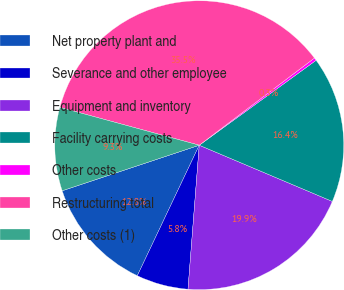<chart> <loc_0><loc_0><loc_500><loc_500><pie_chart><fcel>Net property plant and<fcel>Severance and other employee<fcel>Equipment and inventory<fcel>Facility carrying costs<fcel>Other costs<fcel>Restructuring total<fcel>Other costs (1)<nl><fcel>12.84%<fcel>5.81%<fcel>19.88%<fcel>16.36%<fcel>0.31%<fcel>35.47%<fcel>9.33%<nl></chart> 